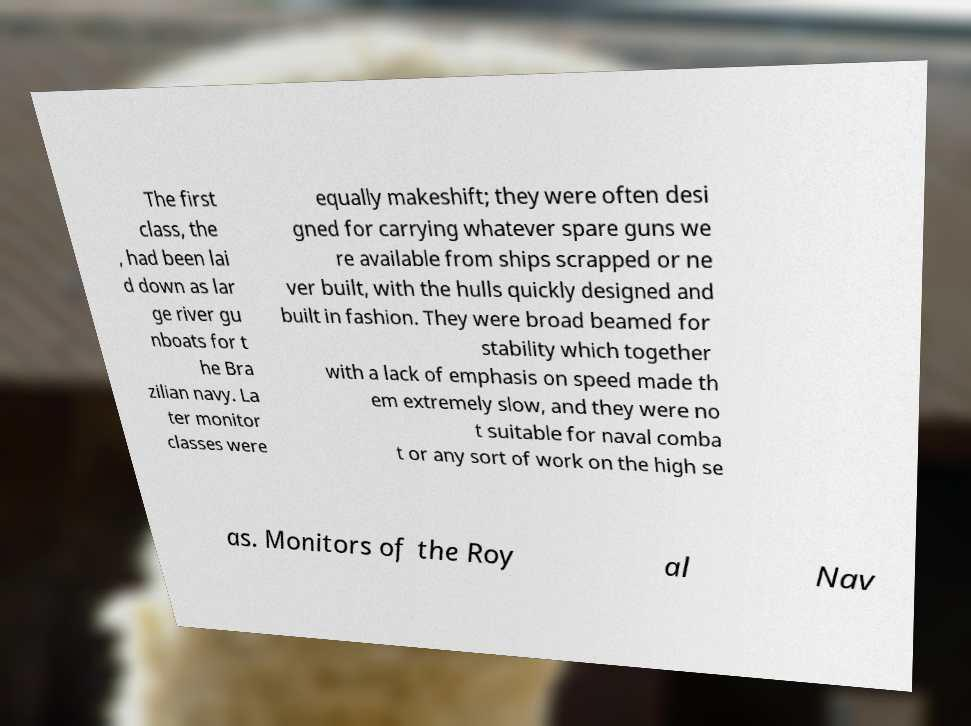For documentation purposes, I need the text within this image transcribed. Could you provide that? The first class, the , had been lai d down as lar ge river gu nboats for t he Bra zilian navy. La ter monitor classes were equally makeshift; they were often desi gned for carrying whatever spare guns we re available from ships scrapped or ne ver built, with the hulls quickly designed and built in fashion. They were broad beamed for stability which together with a lack of emphasis on speed made th em extremely slow, and they were no t suitable for naval comba t or any sort of work on the high se as. Monitors of the Roy al Nav 